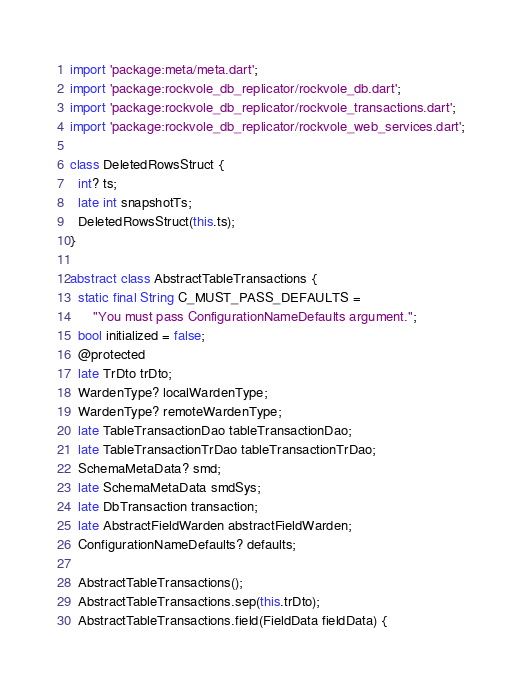Convert code to text. <code><loc_0><loc_0><loc_500><loc_500><_Dart_>import 'package:meta/meta.dart';
import 'package:rockvole_db_replicator/rockvole_db.dart';
import 'package:rockvole_db_replicator/rockvole_transactions.dart';
import 'package:rockvole_db_replicator/rockvole_web_services.dart';

class DeletedRowsStruct {
  int? ts;
  late int snapshotTs;
  DeletedRowsStruct(this.ts);
}

abstract class AbstractTableTransactions {
  static final String C_MUST_PASS_DEFAULTS =
      "You must pass ConfigurationNameDefaults argument.";
  bool initialized = false;
  @protected
  late TrDto trDto;
  WardenType? localWardenType;
  WardenType? remoteWardenType;
  late TableTransactionDao tableTransactionDao;
  late TableTransactionTrDao tableTransactionTrDao;
  SchemaMetaData? smd;
  late SchemaMetaData smdSys;
  late DbTransaction transaction;
  late AbstractFieldWarden abstractFieldWarden;
  ConfigurationNameDefaults? defaults;

  AbstractTableTransactions();
  AbstractTableTransactions.sep(this.trDto);
  AbstractTableTransactions.field(FieldData fieldData) {</code> 